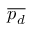Convert formula to latex. <formula><loc_0><loc_0><loc_500><loc_500>\overline { { p _ { d } } }</formula> 